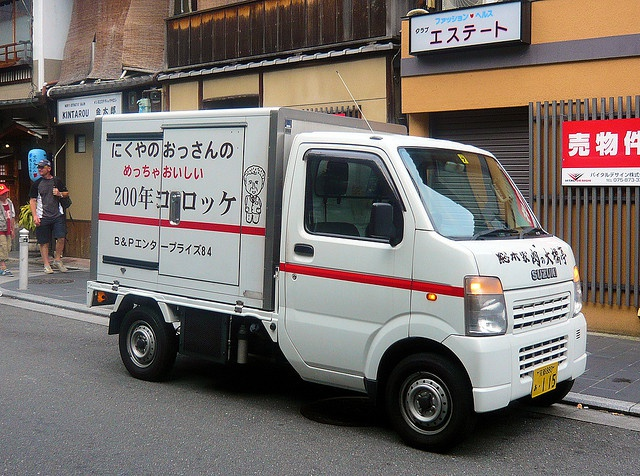Describe the objects in this image and their specific colors. I can see truck in black, darkgray, lightgray, and gray tones, people in black, gray, and brown tones, and people in black, gray, and darkgray tones in this image. 